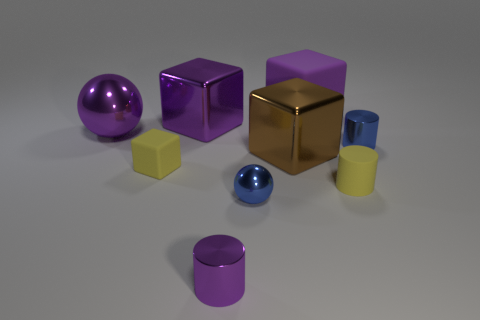Add 1 purple metal cylinders. How many objects exist? 10 Subtract all cylinders. How many objects are left? 6 Add 1 tiny things. How many tiny things are left? 6 Add 8 yellow cylinders. How many yellow cylinders exist? 9 Subtract 2 purple cubes. How many objects are left? 7 Subtract all big red metallic cubes. Subtract all tiny blue spheres. How many objects are left? 8 